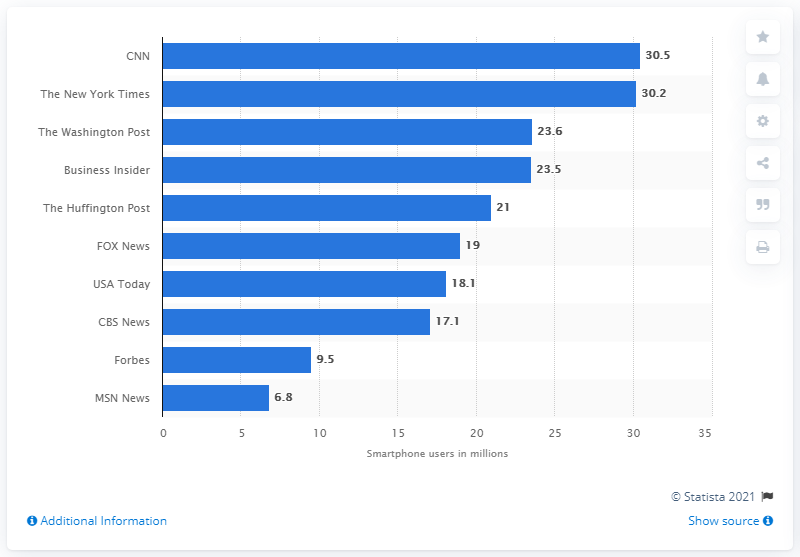Draw attention to some important aspects in this diagram. According to a report, 30.5 consumers accessed CNN's content via their smartphone. 